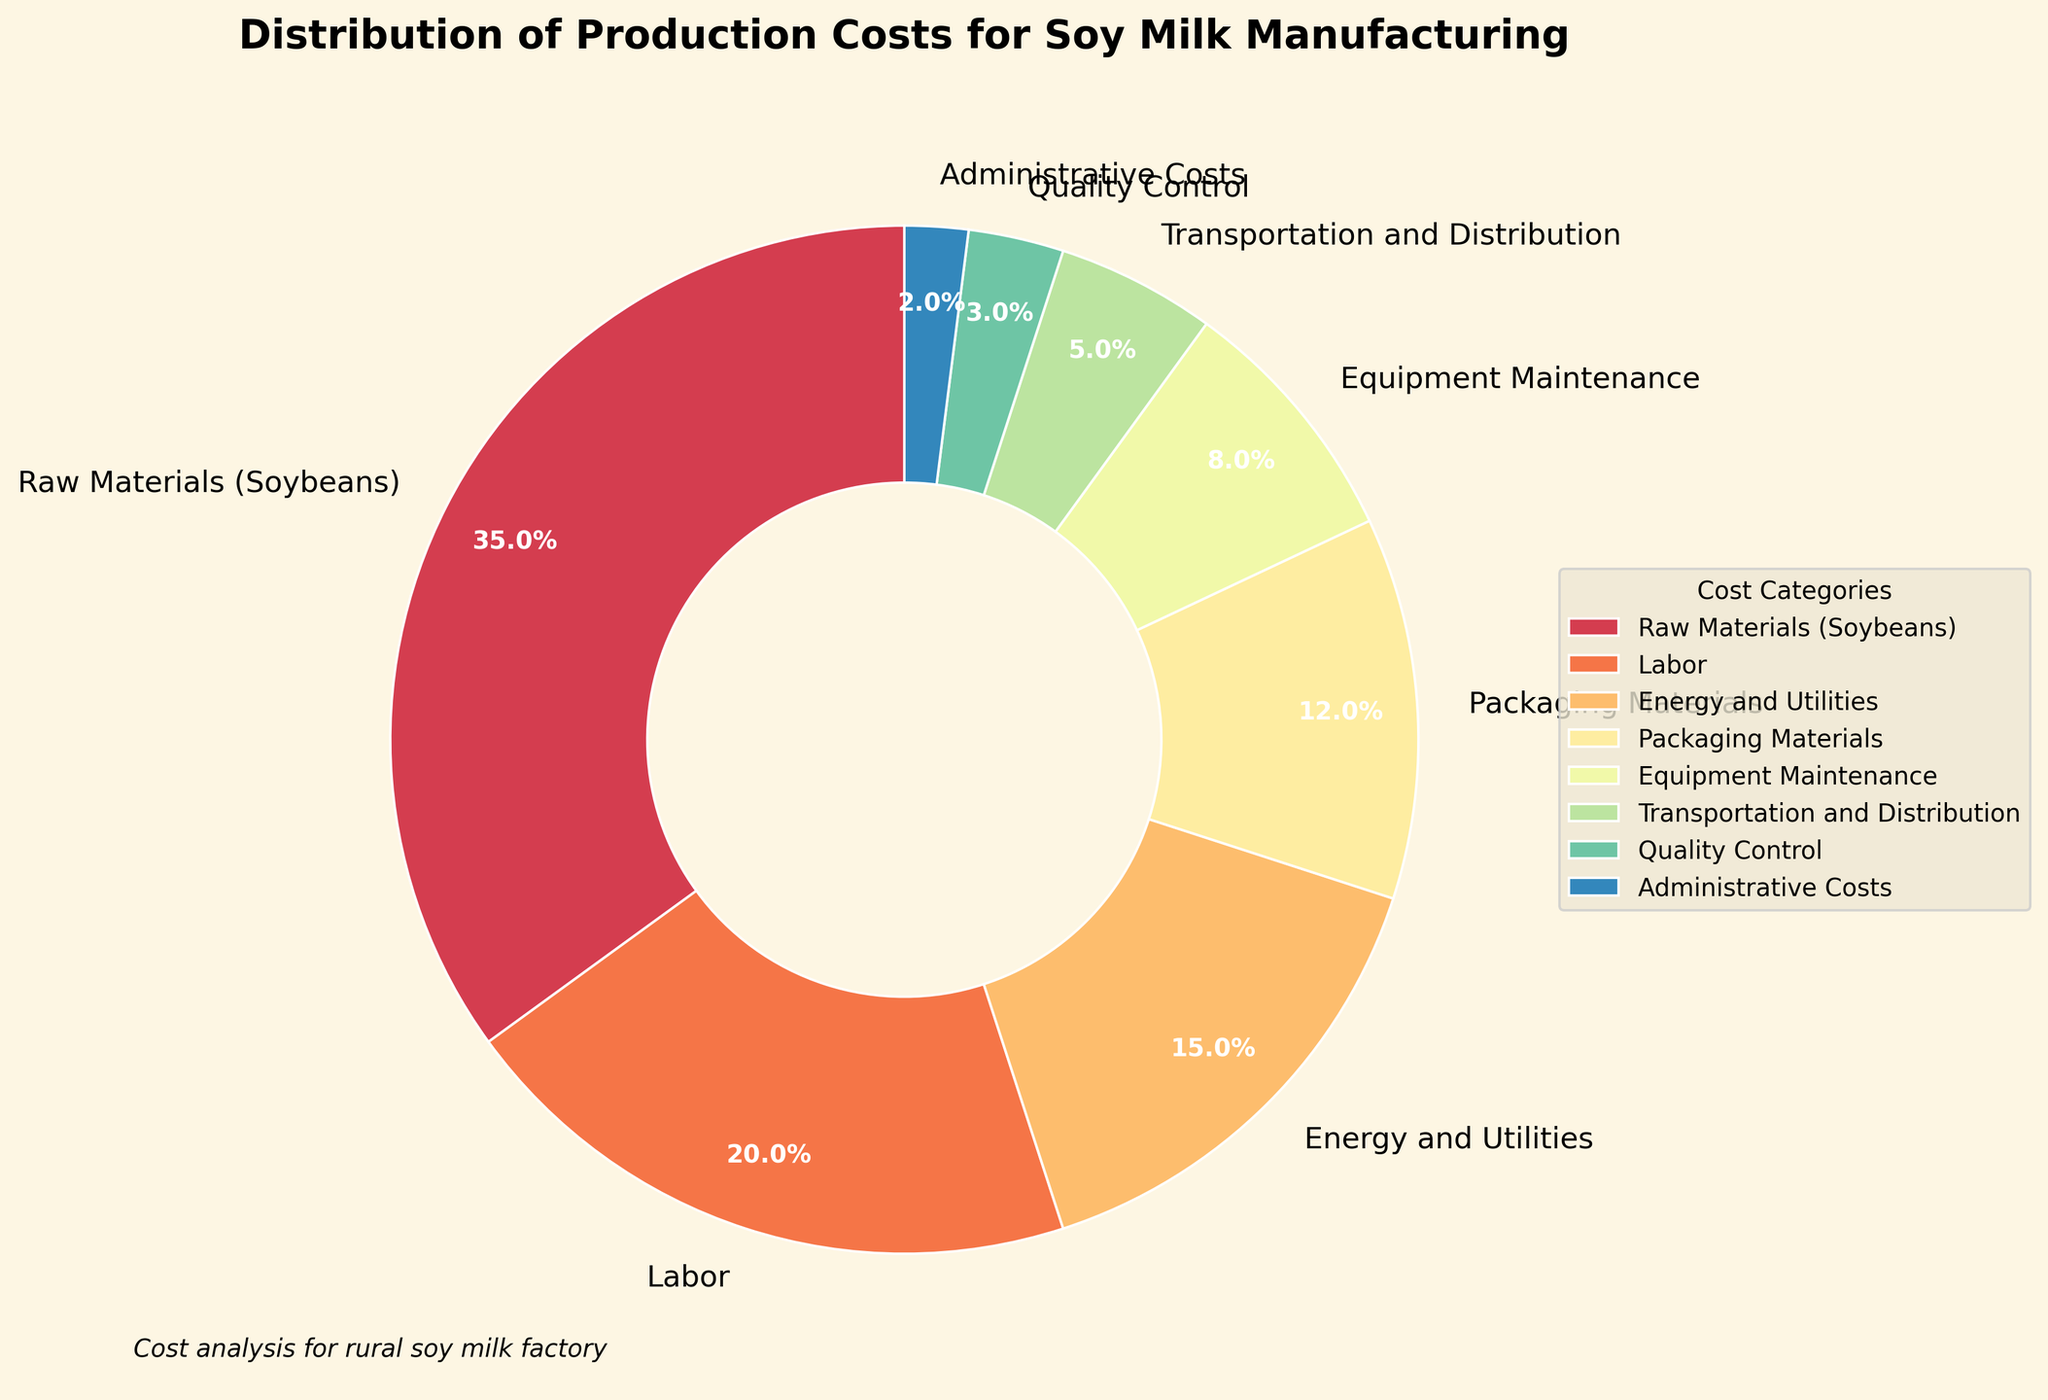What percentage of the total production cost is contributed by administrative costs and quality control combined? To find the combined percentage, we add the percentages of the administrative costs (2%) and quality control (3%). The combined percentage is 2% + 3% = 5%.
Answer: 5% Which cost category has the largest share of the total production cost? By inspecting the pie chart, we see that 'Raw Materials (Soybeans)' has the largest share, accounting for 35% of the total production cost.
Answer: Raw Materials (Soybeans) How much more percentage is spent on labor compared to transportation and distribution? By examining the chart, the labor cost is 20% and transportation and distribution is 5%. The difference is 20% - 5% = 15%.
Answer: 15% Is the percentage of costs spent on packaging materials greater than the sum of the costs for equipment maintenance and administrative costs? The percentage for packaging materials is 12%. For equipment maintenance, it's 8%, and for administrative costs, it's 2%. The sum of equipment maintenance and administrative costs is 8% + 2% = 10%. Since 12% (packaging materials) is greater than 10%, the answer is yes.
Answer: Yes What is the total percentage of costs attributed to categories other than raw materials and labor? Raw materials account for 35% and labor accounts for 20%. The total percentage is 100%. Subtracting these two, we have 100% - 35% - 20% = 45%.
Answer: 45% Which categories together constitute less than one-quarter of the total production cost? One-quarter of the total cost is 25%. Adding smaller categories together, we find:
Energy and Utilities (15%) + Packaging Materials (12%) = 27% (greater than 25%)
Equipment Maintenance (8%) + Transportation and Distribution (5%) = 13%
Equipment Maintenance (8%) + Quality Control (3%) + Administrative Costs (2%) = 13%
Thus, 'Equipment Maintenance', 'Transportation and Distribution', 'Quality Control', and 'Administrative Costs' together constitute less than 25%.
Answer: Equipment Maintenance, Transportation and Distribution, Quality Control, Administrative Costs Are there more categories with costs greater than or equal to 10% or fewer? Categories with costs greater than or equal to 10% are:
- Raw Materials (Soybeans) (35%)
- Labor (20%)
- Energy and Utilities (15%)
- Packaging Materials (12%)
That is 4 categories. Categories with costs less than 10% are:
- Equipment Maintenance (8%)
- Transportation and Distribution (5%)
- Quality Control (3%)
- Administrative Costs (2%)
That is 4 categories. Thus, there are an equal number (4 each).
Answer: Equal number Which category in the chart uses the darkest color? By inspection of the pie chart, the 'Raw Materials (Soybeans)' category uses the darkest color.
Answer: Raw Materials (Soybeans) If costs were cut equally in every category by 1%, what would the new percentage for labor be? Initially, labor is 20%. Subtracting 1%, we have 20% - 1% = 19%.
Answer: 19% What is the combined cost percentage of the three largest categories? The largest categories are 'Raw Materials (Soybeans)' (35%), 'Labor' (20%), and 'Energy and Utilities' (15%). Adding these percentages together, 35% + 20% + 15% = 70%.
Answer: 70% 